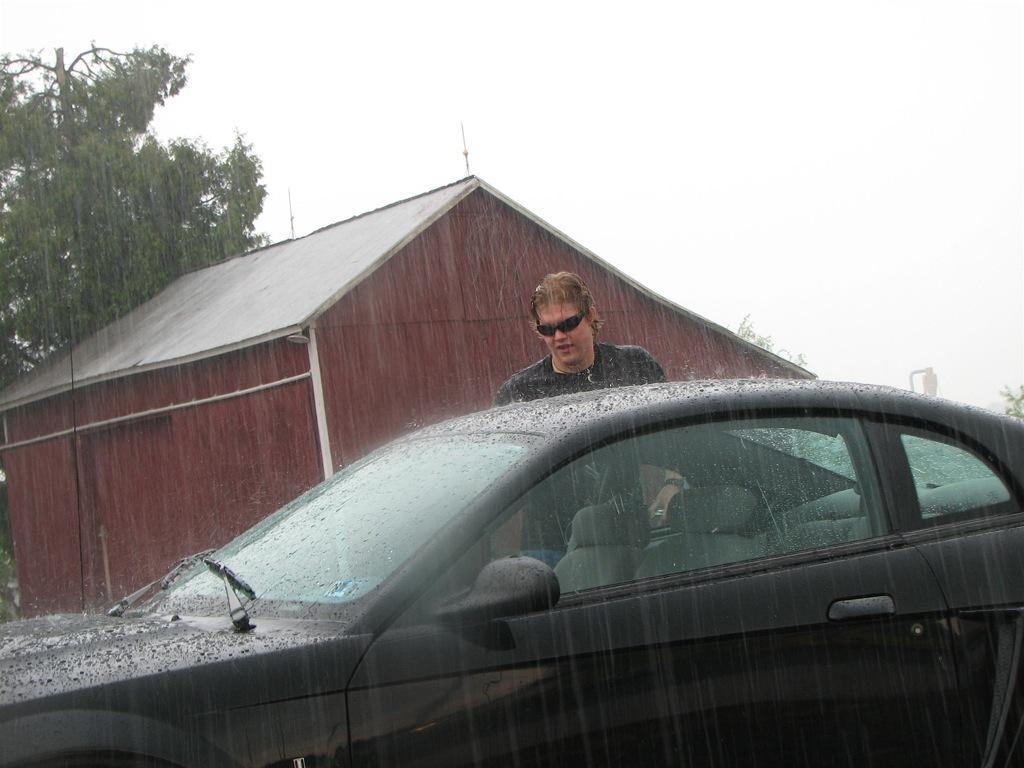Describe this image in one or two sentences. In this image there is a car , behind the car a man is standing , in the background there is a house and a tree and it is raining. 